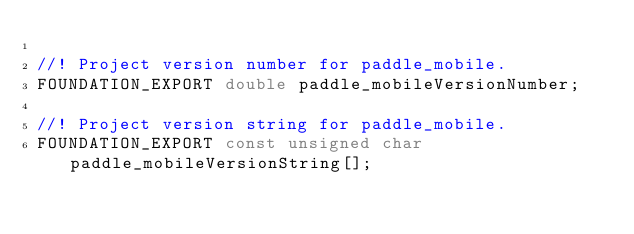Convert code to text. <code><loc_0><loc_0><loc_500><loc_500><_C_>
//! Project version number for paddle_mobile.
FOUNDATION_EXPORT double paddle_mobileVersionNumber;

//! Project version string for paddle_mobile.
FOUNDATION_EXPORT const unsigned char paddle_mobileVersionString[];


</code> 